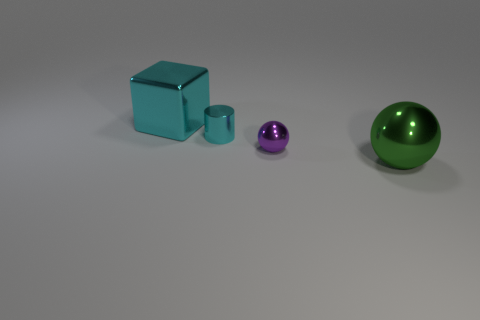Is the number of tiny cyan things behind the large green metallic object less than the number of small metal cylinders?
Give a very brief answer. No. There is a large shiny object to the right of the large cyan metallic cube; what is its color?
Keep it short and to the point. Green. What shape is the large cyan thing?
Offer a terse response. Cube. Is there a thing that is on the left side of the big metal object that is behind the ball that is behind the big sphere?
Your answer should be compact. No. What is the color of the metal thing left of the cyan thing that is to the right of the big object behind the big shiny sphere?
Ensure brevity in your answer.  Cyan. There is another thing that is the same shape as the purple thing; what is its material?
Provide a short and direct response. Metal. There is a cyan metal object that is on the right side of the large metal thing that is behind the green metallic ball; what size is it?
Your answer should be very brief. Small. What material is the tiny thing that is in front of the cylinder?
Keep it short and to the point. Metal. What is the size of the purple object that is made of the same material as the cyan cube?
Give a very brief answer. Small. How many large metallic things are the same shape as the tiny purple thing?
Keep it short and to the point. 1. 